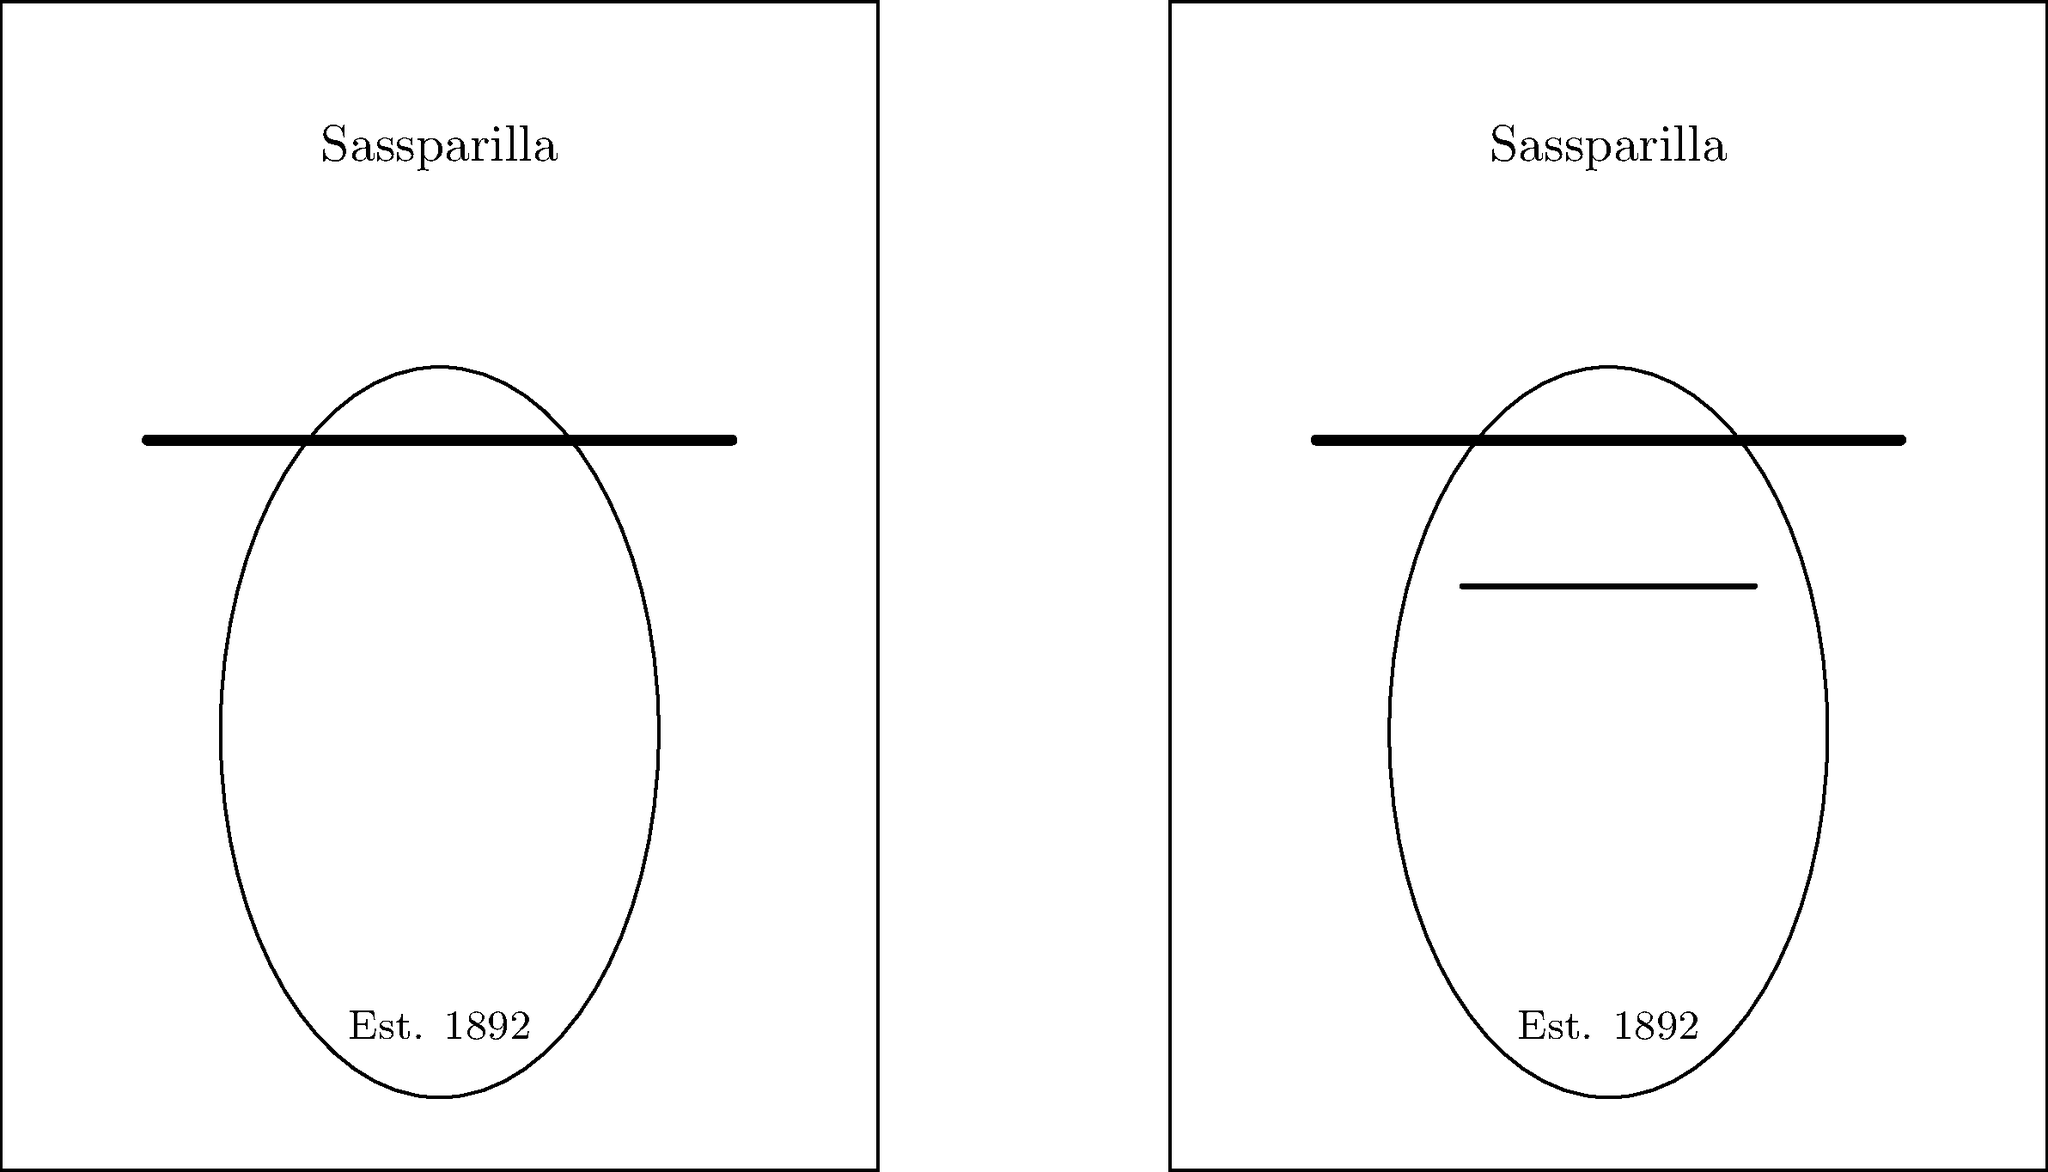Compare the two vintage Sassparilla advertisement posters. How many differences can you spot between them? To find the differences between the two vintage Sassparilla advertisement posters, let's compare them element by element:

1. Overall layout: Both posters have the same rectangular shape and size.
2. Brand name: "Sassparilla" is written at the top of both posters in the same font and size.
3. Horizontal line: Both posters have a thick horizontal line below the brand name.
4. Central oval shape: Both posters feature an identical oval shape in the center.
5. Establishment year: "Est. 1892" is written at the bottom of both posters in the same font and size.
6. Additional element: The poster on the right has an extra horizontal line within the oval shape, which is not present in the left poster.

After careful examination, we can conclude that there is only one difference between the two posters: the additional horizontal line in the right poster's oval shape.
Answer: 1 